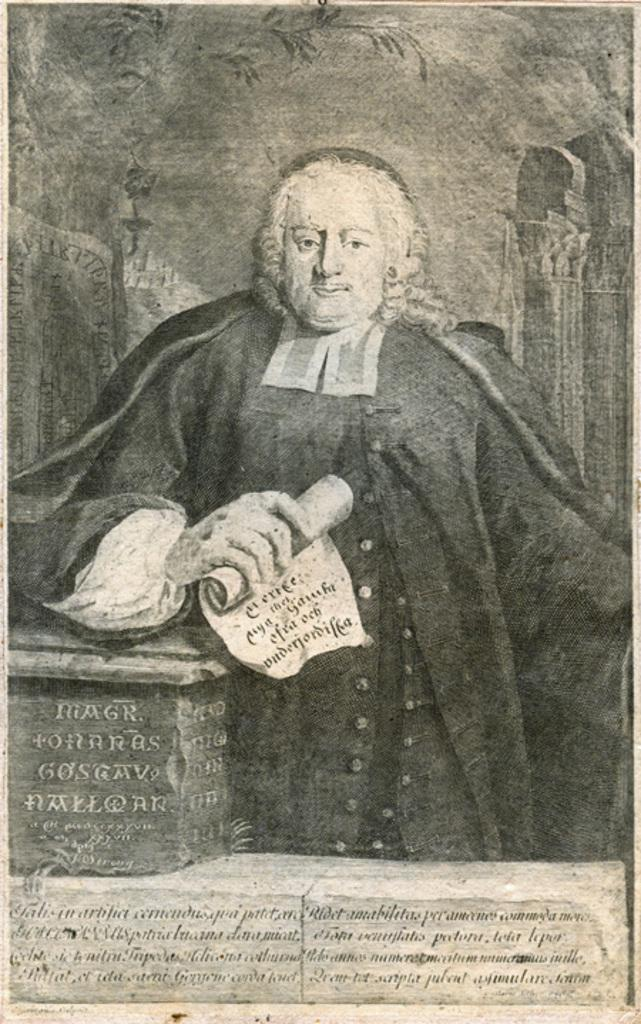What is featured on the poster in the image? The poster contains an image of a man. What is the man doing in the image on the poster? The man is standing near a table and a cupboard. What is the man holding in the image on the poster? The man is holding a paper. What type of polish is the man applying to his boots in the image? There is no mention of polish or boots in the image; the man is holding a paper and standing near a table and a cupboard. 